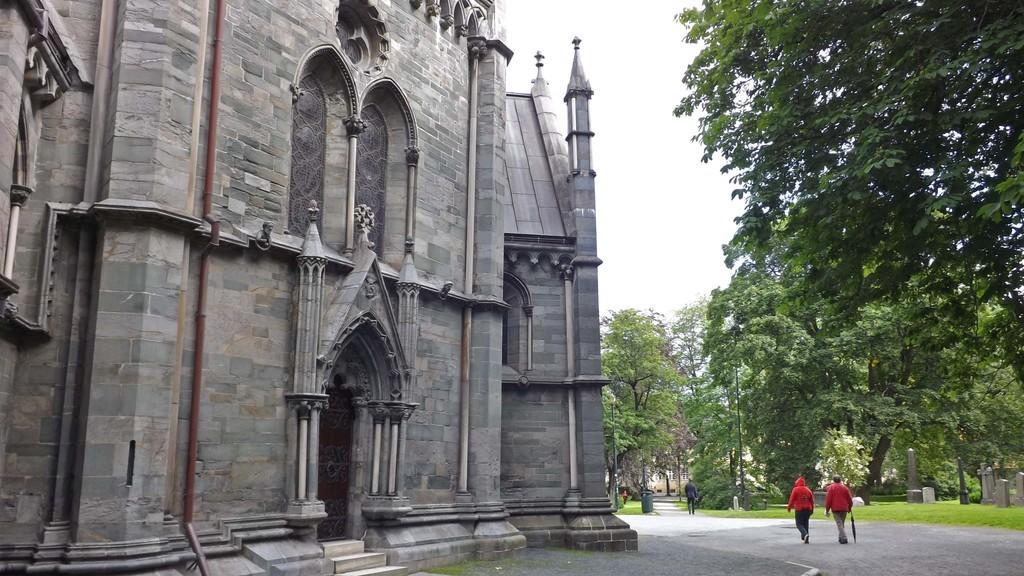How would you summarize this image in a sentence or two? In this picture there are people and we can see ground, grass, graveyard, trees, dustbin and building. In the background of the image we can see the sky. 